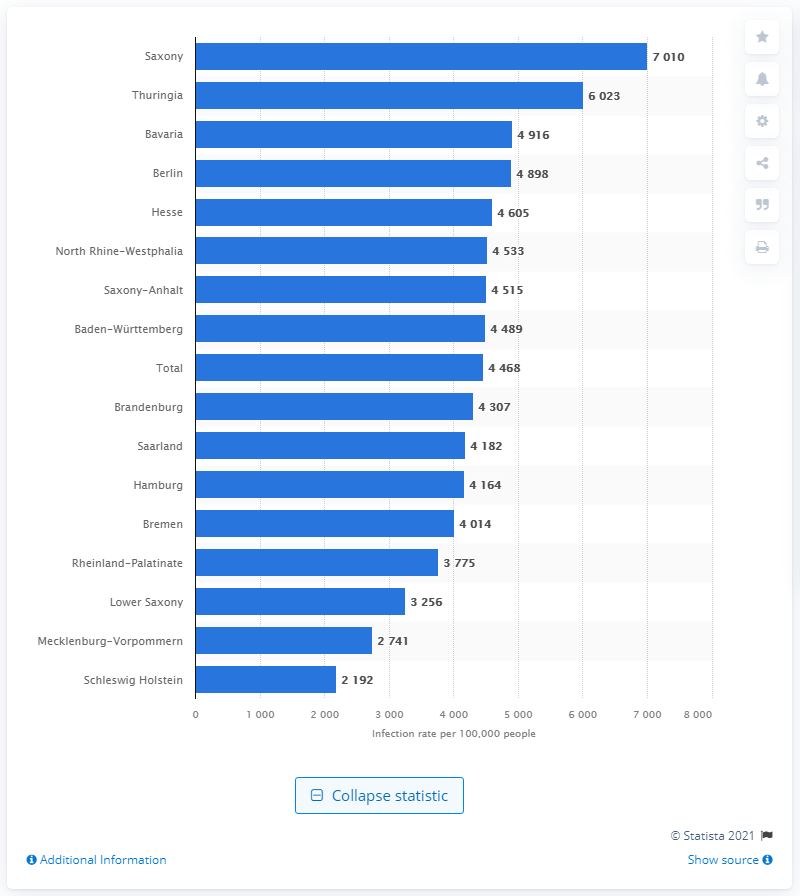Give some essential details in this illustration. Saxony has the highest rate of infection per 100,000 inhabitants among all the states in Germany. 